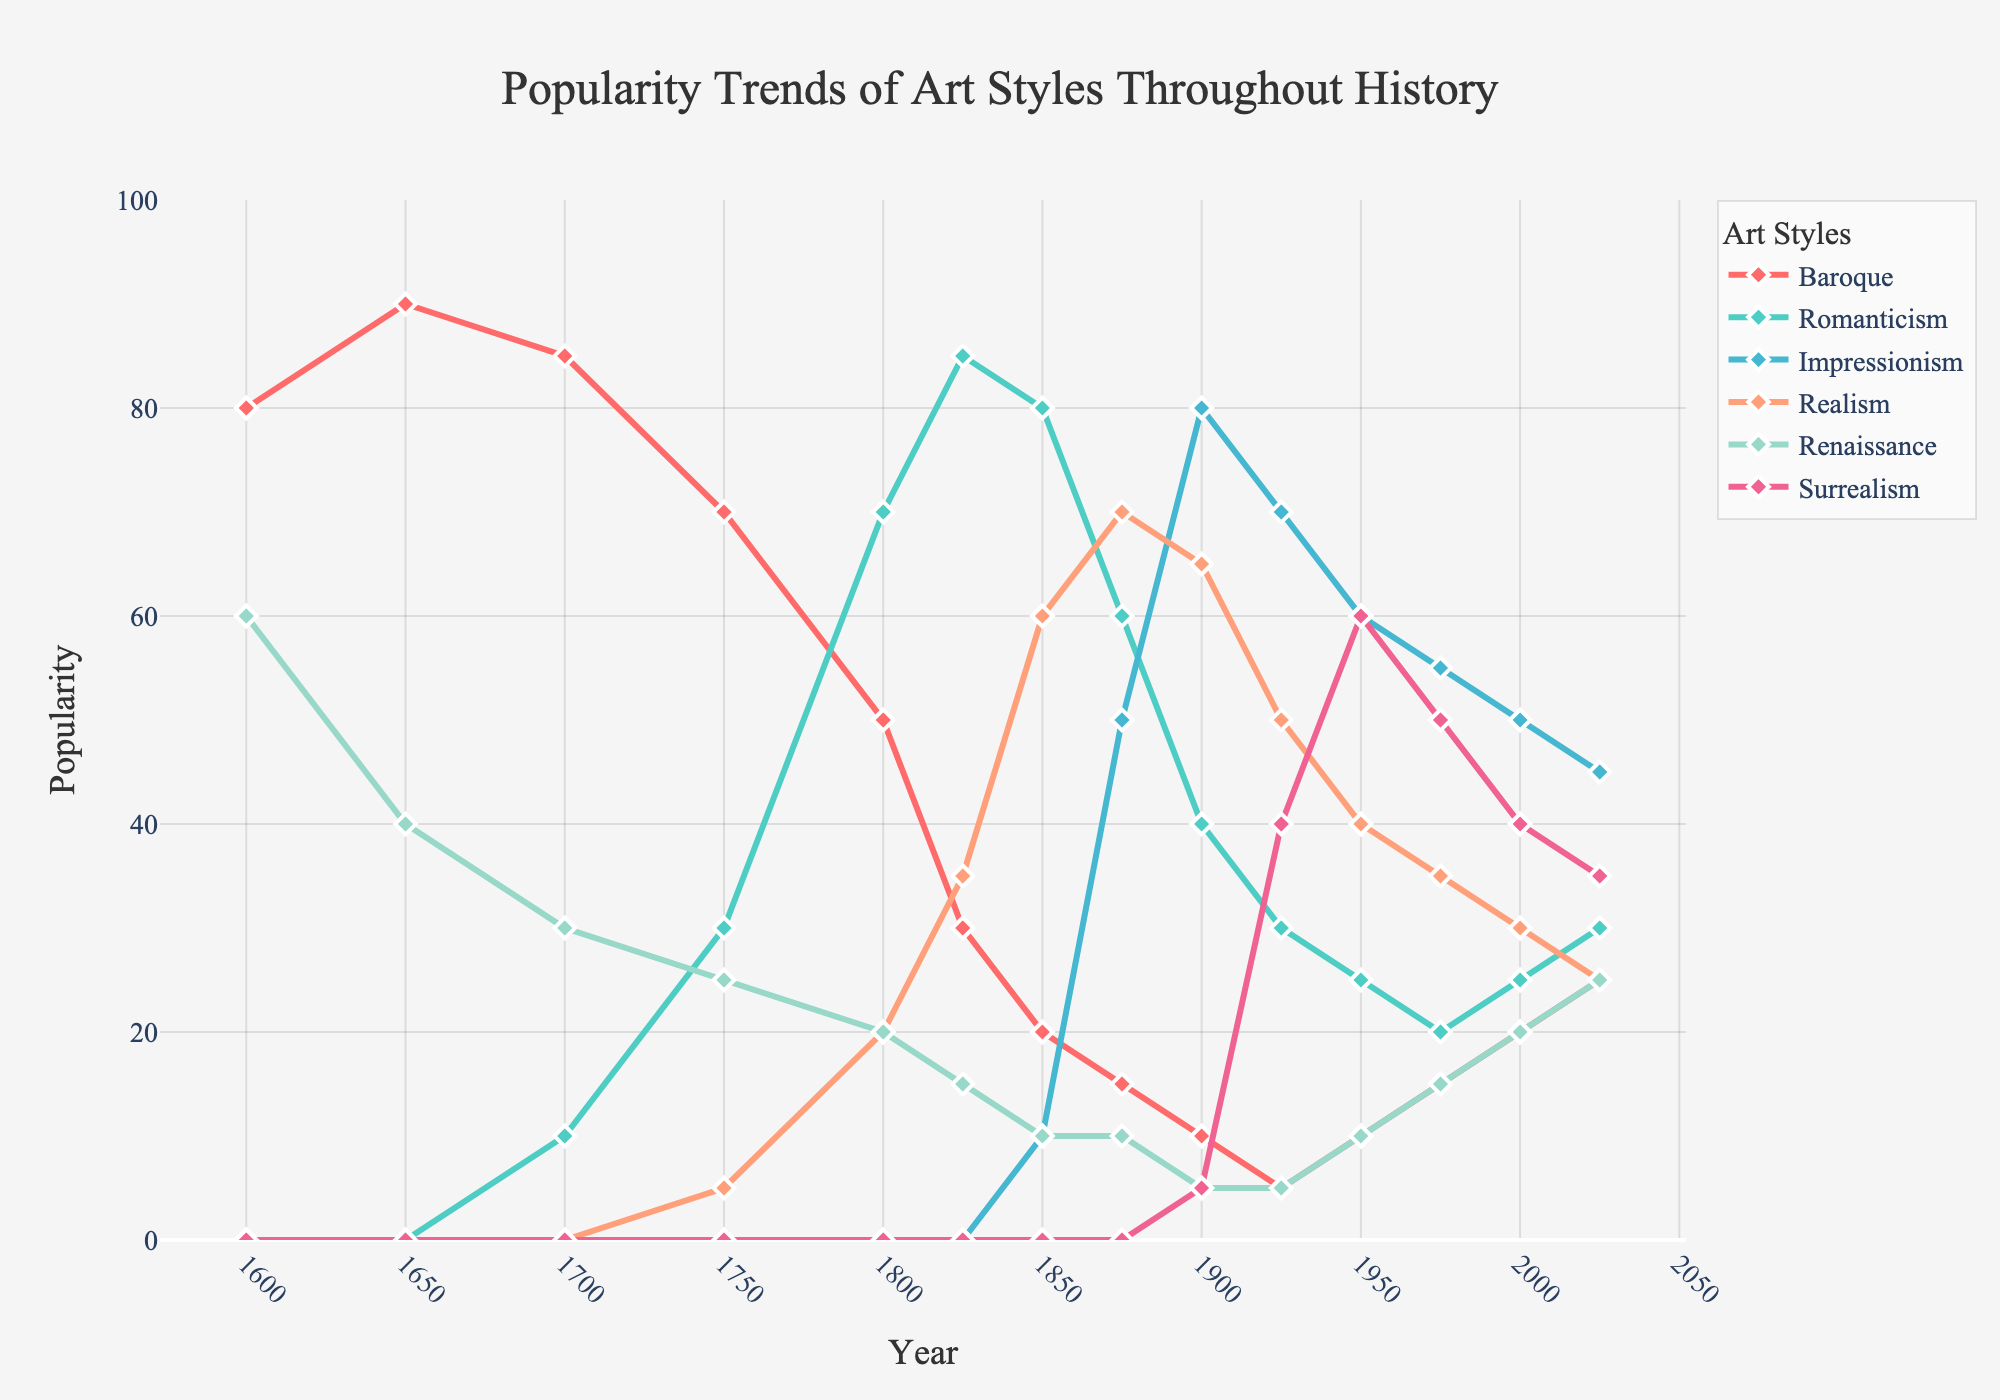Which art style was the most popular in 1600? The figure shows that the "Baroque" art style has the highest popularity in 1600 with a value of 80.
Answer: Baroque How did the popularity of the Impressionism style change from 1850 to 1900? To find the change, look at the graph and note the values for Impressionism in 1850 (10) and 1900 (80). The change is 80 - 10 = 70.
Answer: Increased by 70 Which two art styles had equal popularity in 2025? In 2025, the graph shows that "Renaissance" and "Baroque" both have a popularity value of 25.
Answer: Renaissance and Baroque During which period did Romanticism see its peak in popularity? The peak popularity for Romanticism occurs around 1825, where it reaches the highest value of 85.
Answer: Around 1825 Compare the popularity of Realism and Surrealism in 1950. Which was more popular? In 1950, Realism has a popularity value of 40, whereas Surrealism has a value of 60. Surrealism is more popular.
Answer: Surrealism What is the average popularity of the Renaissance style across all years provided? The average popularity can be calculated by summing the Renaissance values (60 + 40 + 30 + 25 + 20 + 15 + 10 + 5 + 5 + 10 + 15 + 20 + 25 = 280) and dividing by the number of data points (13). 280 / 13 ≈ 21.54.
Answer: Approximately 21.54 Which art style experienced the most significant decline in popularity from its peak to its lowest point through the years? Analyze the peaks and troughs in popularity for each art style and note the changes. Baroque declines from its peak of 90 in 1650 to 5 in 1925, making it a drop of 85. No other style shows a greater decline.
Answer: Baroque What was the trend of Surrealism from 1925 to 2000? Observing the values for Surrealism from 1925 (40), 1950 (60), 1975 (50), and 2000 (40), the trend shows an initial increase, followed by a slight decrease.
Answer: Initial increase, then decrease By how much did Realism's popularity exceed Renaissance's in 1875? In 1875, Realism has a popularity value of 70, while Renaissance has 10. The difference is 70 - 10 = 60.
Answer: By 60 Which period saw an equal popularity for Baroque and Realism? In 2000, both Baroque and Realism have a popularity value of 20.
Answer: 2000 